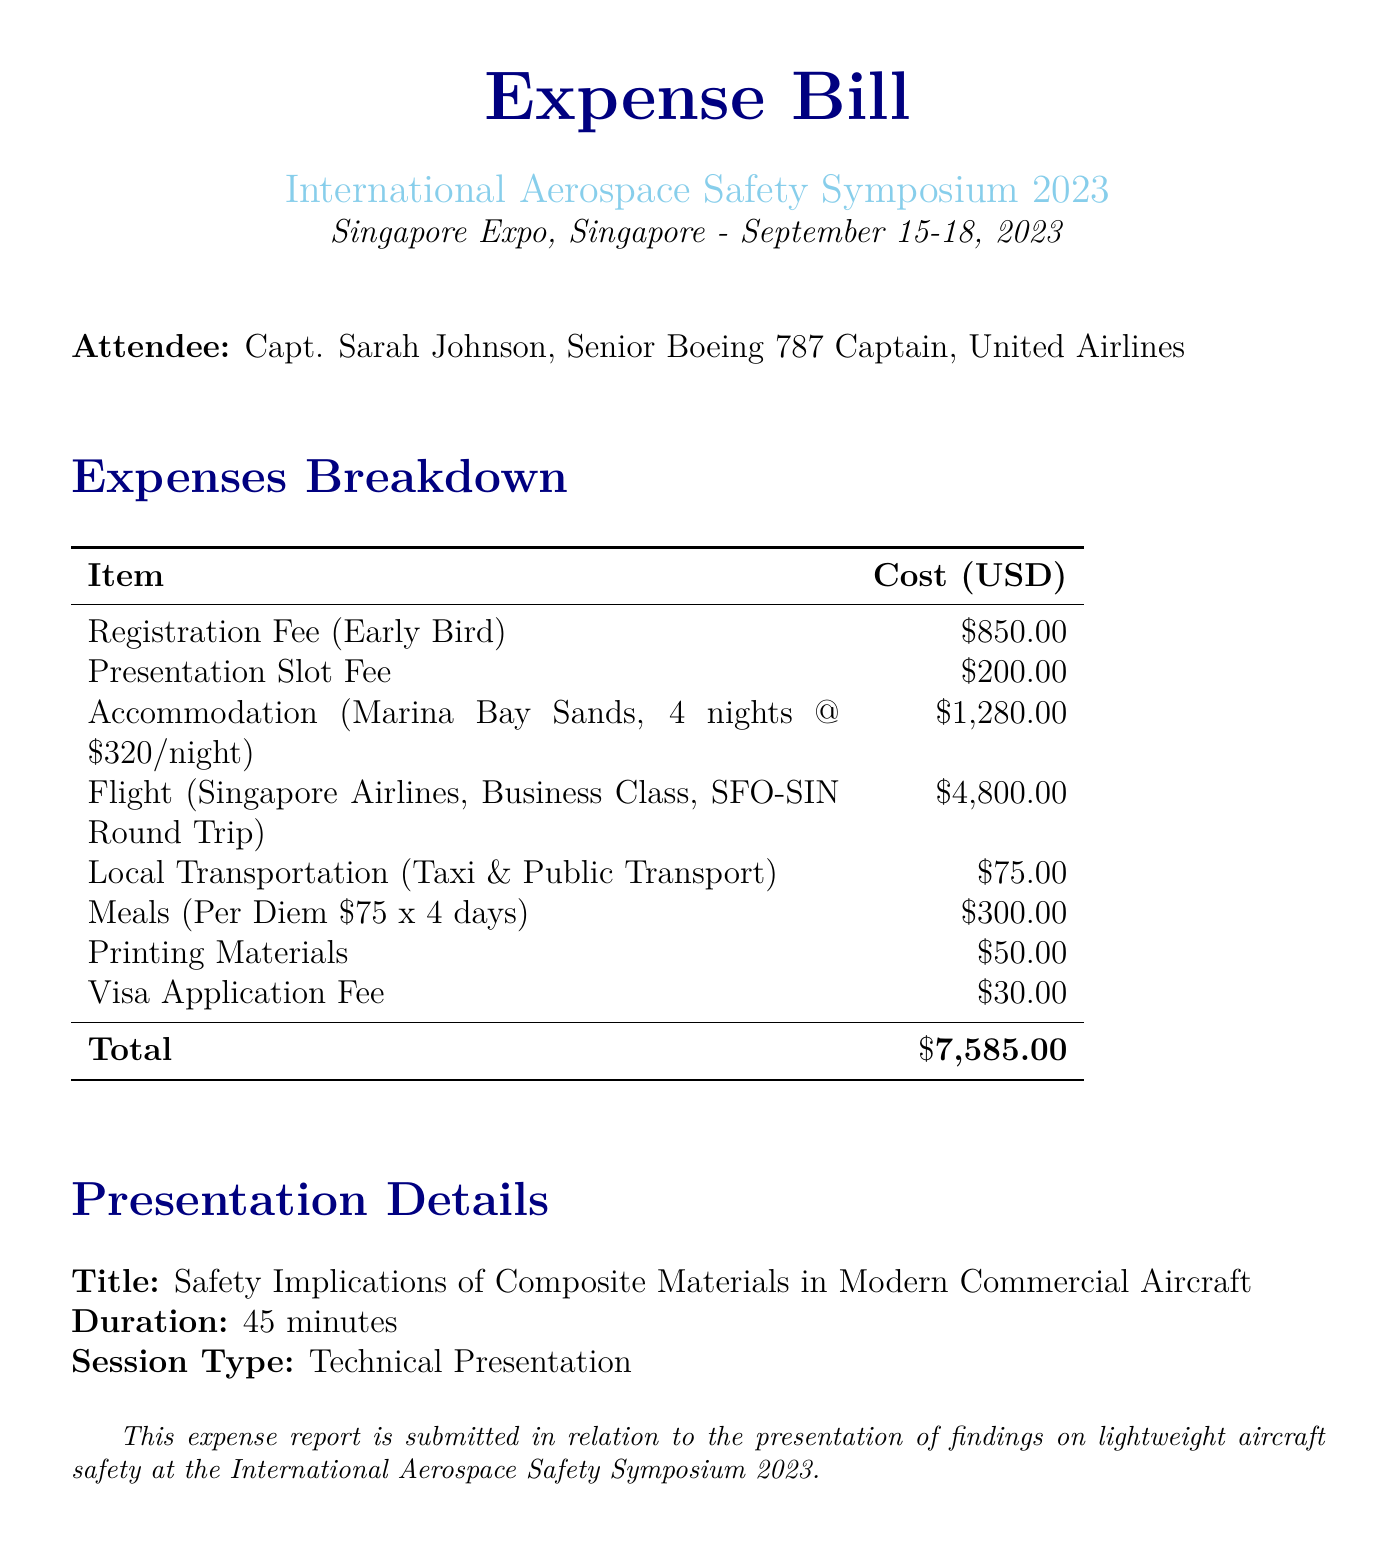What is the total cost of the expenses? The total cost is stated explicitly at the bottom of the expenses table, summing all costs listed.
Answer: $7,585.00 What is the venue for the conference? The venue is mentioned at the top of the document, describing where the conference is held.
Answer: Singapore Expo Who is the attendee of the symposium? The attendee's name and position are clearly indicated at the beginning of the document.
Answer: Capt. Sarah Johnson How many nights was the accommodation booked for? The accommodation details include the number of nights stayed at the hotel for the conference.
Answer: 4 nights What was the presentation title? The title of the presentation is specified under the presentation details section of the document.
Answer: Safety Implications of Composite Materials in Modern Commercial Aircraft What was the registration fee amount? The registration fee is listed separately in the expenses breakdown table.
Answer: $850.00 What type of transportation costs are included in the expenses? The document specifies the types of transportation for which expenses were incurred.
Answer: Taxi & Public Transport What is the duration of the presentation? The duration of the presentation is explicitly stated in the presentation details section.
Answer: 45 minutes 